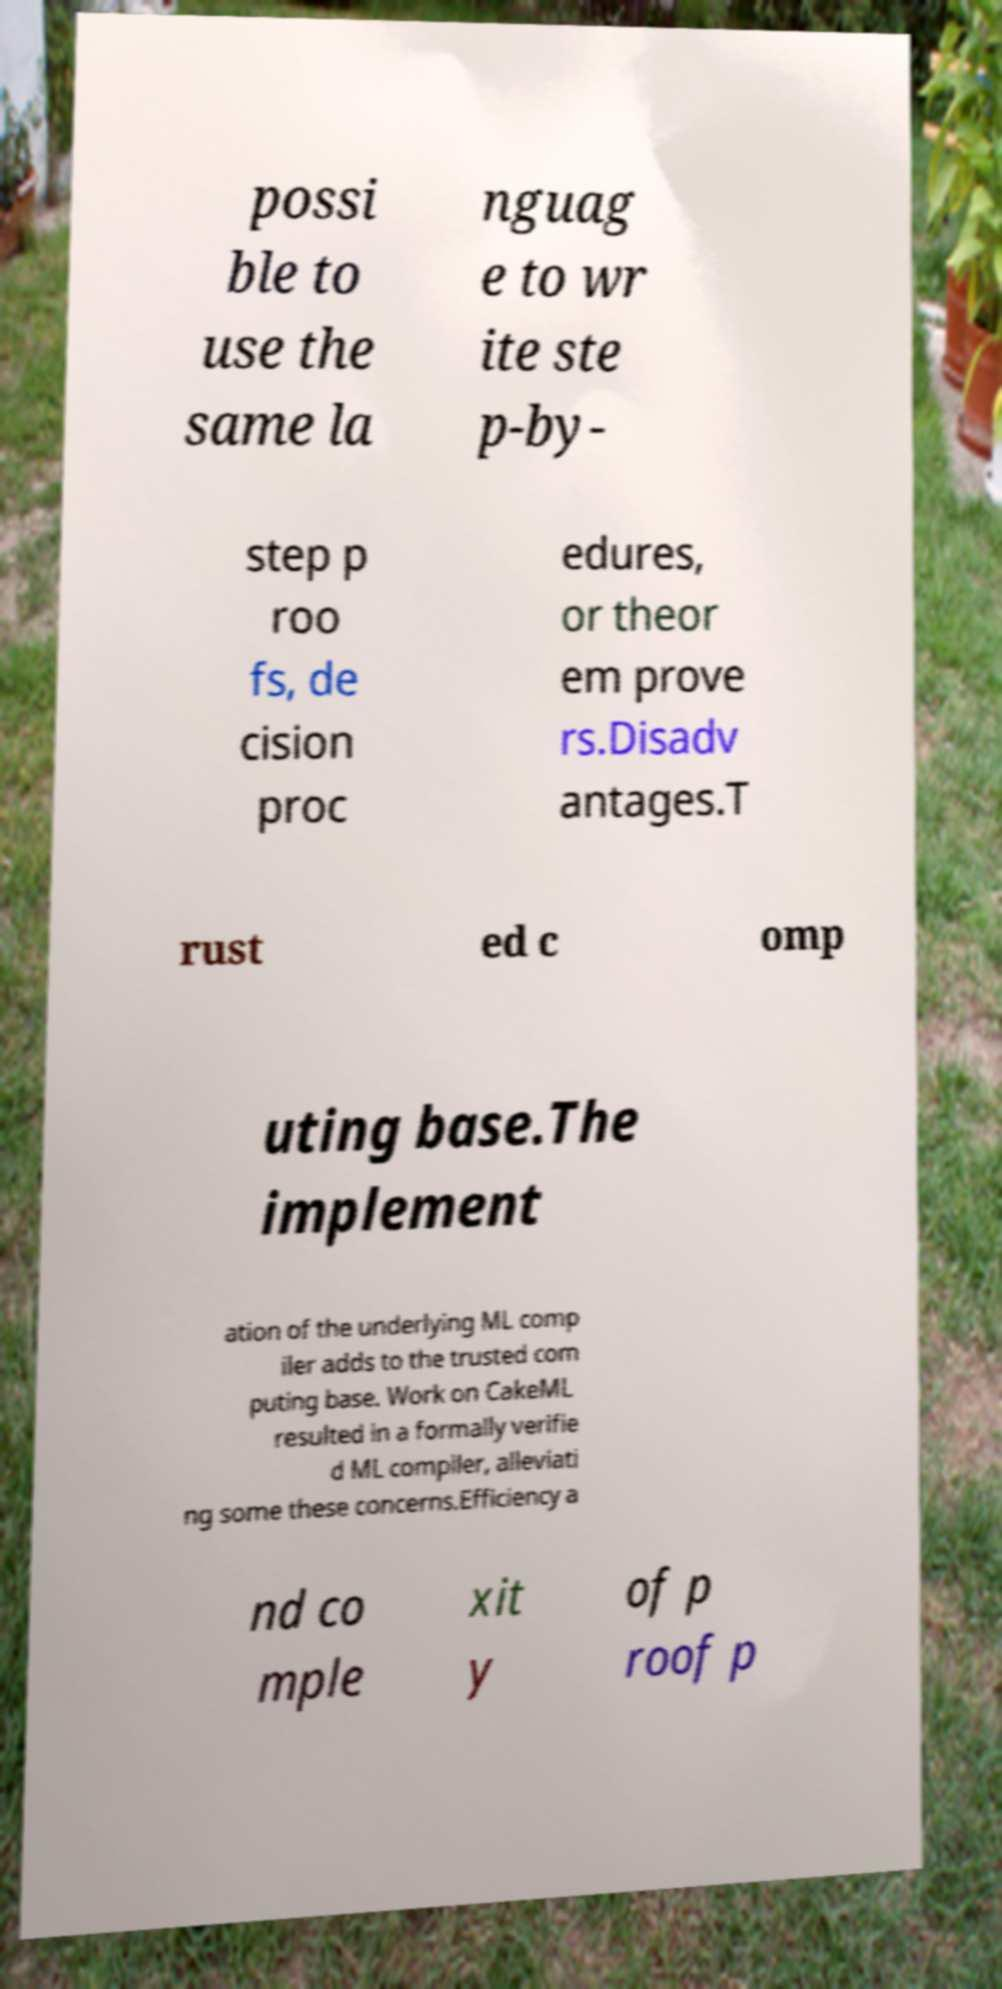Can you accurately transcribe the text from the provided image for me? possi ble to use the same la nguag e to wr ite ste p-by- step p roo fs, de cision proc edures, or theor em prove rs.Disadv antages.T rust ed c omp uting base.The implement ation of the underlying ML comp iler adds to the trusted com puting base. Work on CakeML resulted in a formally verifie d ML compiler, alleviati ng some these concerns.Efficiency a nd co mple xit y of p roof p 